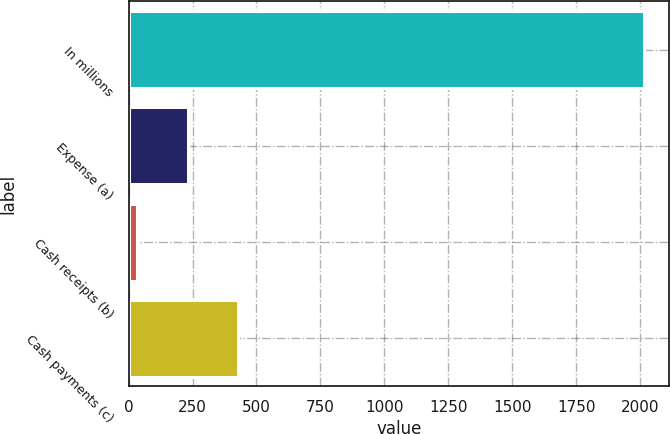Convert chart. <chart><loc_0><loc_0><loc_500><loc_500><bar_chart><fcel>In millions<fcel>Expense (a)<fcel>Cash receipts (b)<fcel>Cash payments (c)<nl><fcel>2013<fcel>231<fcel>33<fcel>429<nl></chart> 